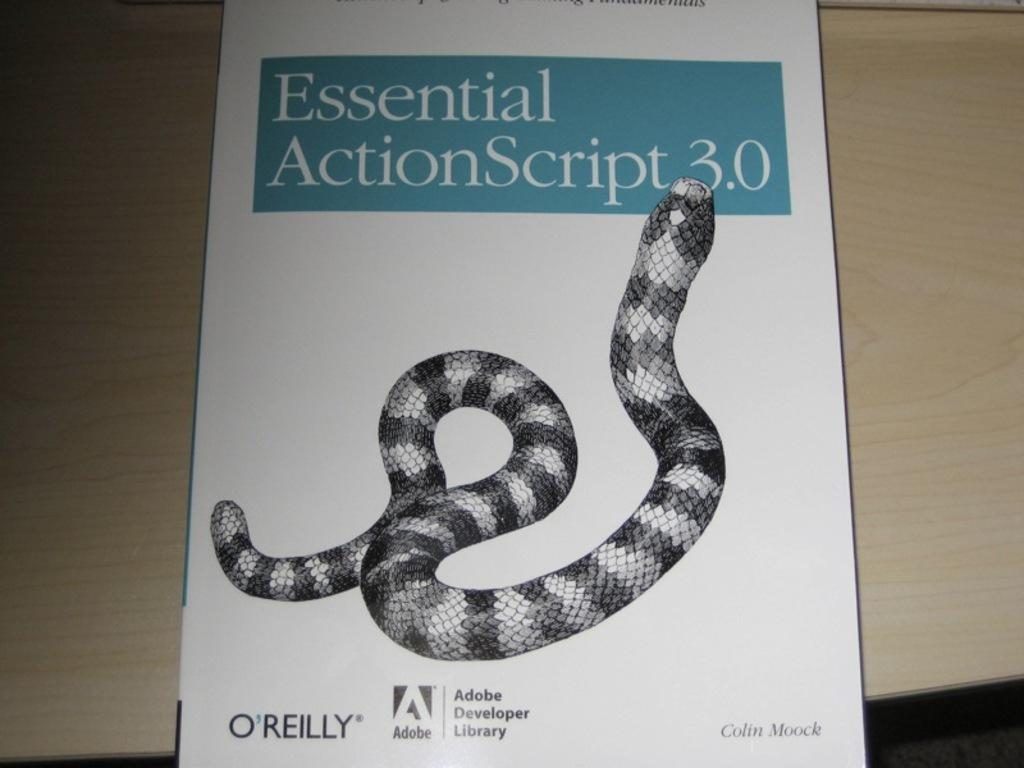What object can be seen in the image? There is a book in the image. Where is the book placed? The book is placed on a wooden table. What design or image is on the book? The book has a black and white color snake printed on it. Is there a picture of a cellar on the book? No, there is no picture of a cellar on the book; it has a black and white color snake printed on it. 